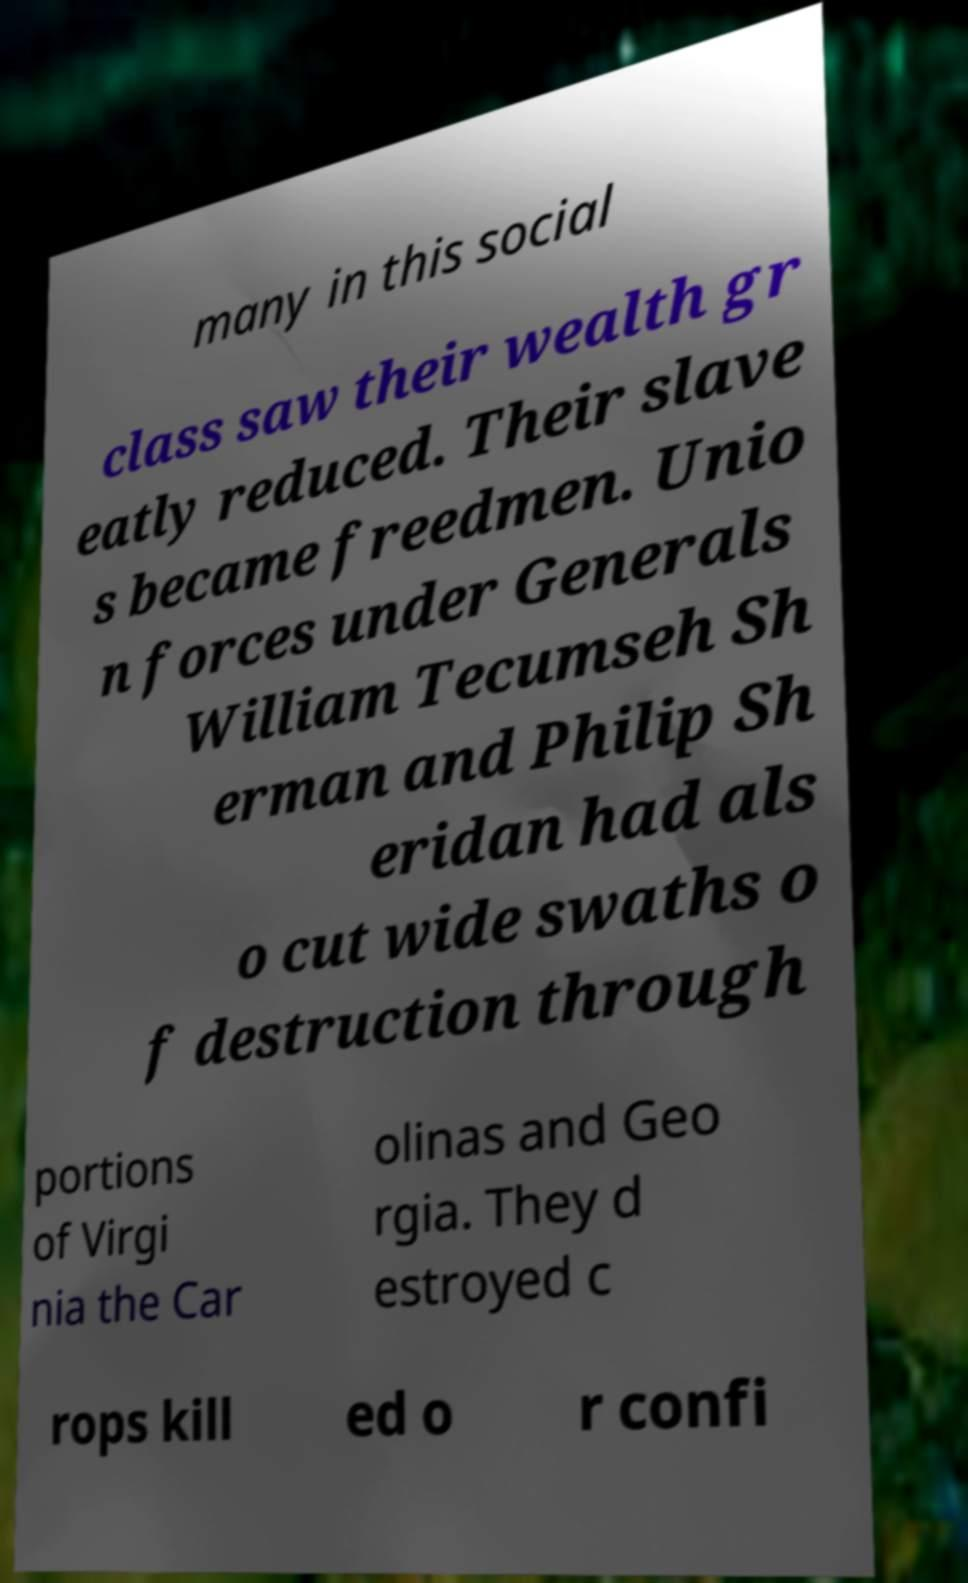For documentation purposes, I need the text within this image transcribed. Could you provide that? many in this social class saw their wealth gr eatly reduced. Their slave s became freedmen. Unio n forces under Generals William Tecumseh Sh erman and Philip Sh eridan had als o cut wide swaths o f destruction through portions of Virgi nia the Car olinas and Geo rgia. They d estroyed c rops kill ed o r confi 